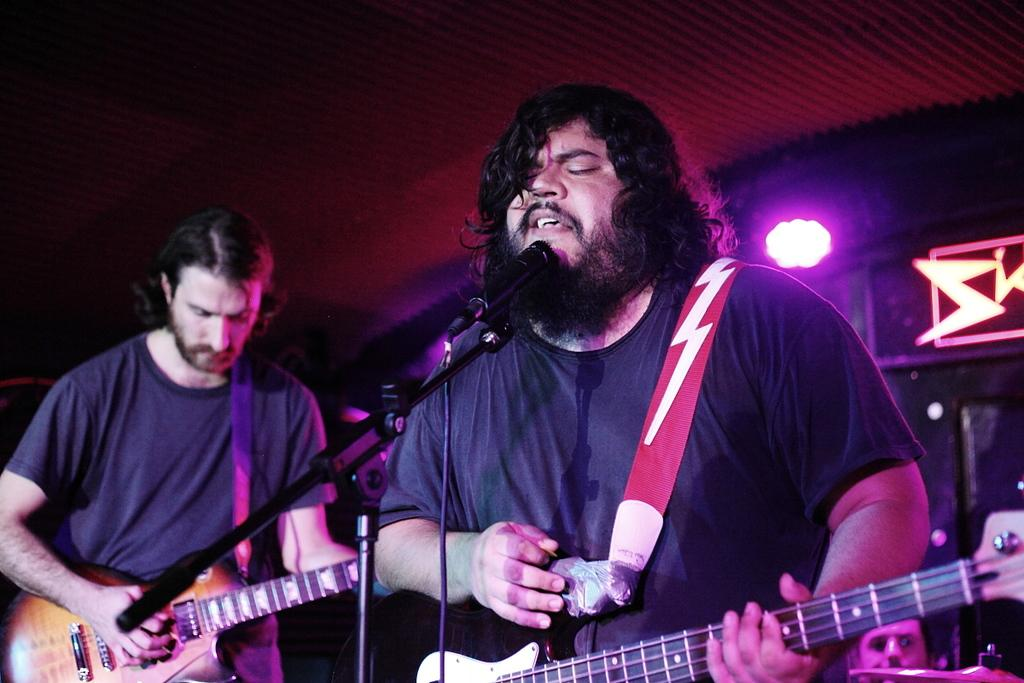How many people are in the image? There are two persons in the image. What are the two persons doing? One of the persons is playing a guitar, and the other person is singing on a microphone. Can you describe the background of the image? There is a light visible in the background. What type of substance is being measured by the appliance in the image? There is no appliance or substance present in the image; it features two people performing musical activities. 